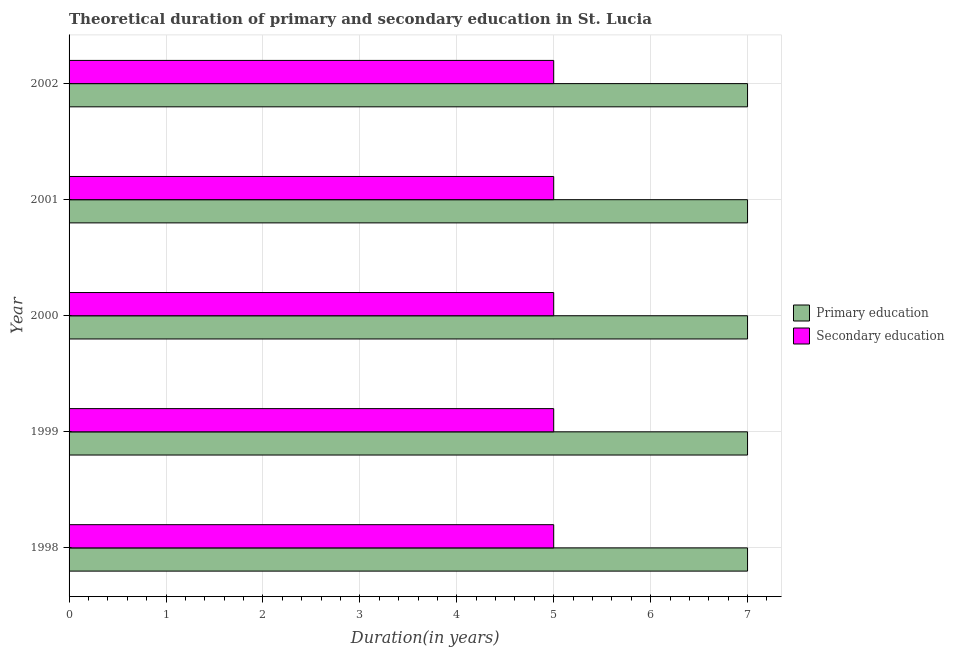Are the number of bars per tick equal to the number of legend labels?
Your answer should be compact. Yes. Are the number of bars on each tick of the Y-axis equal?
Provide a succinct answer. Yes. How many bars are there on the 2nd tick from the bottom?
Your answer should be compact. 2. In how many cases, is the number of bars for a given year not equal to the number of legend labels?
Give a very brief answer. 0. What is the duration of secondary education in 1998?
Give a very brief answer. 5. Across all years, what is the maximum duration of primary education?
Make the answer very short. 7. Across all years, what is the minimum duration of primary education?
Provide a short and direct response. 7. In which year was the duration of secondary education maximum?
Make the answer very short. 1998. What is the total duration of secondary education in the graph?
Give a very brief answer. 25. What is the difference between the duration of secondary education in 2002 and the duration of primary education in 1999?
Give a very brief answer. -2. In the year 1998, what is the difference between the duration of primary education and duration of secondary education?
Offer a terse response. 2. In how many years, is the duration of secondary education greater than 3.4 years?
Your answer should be compact. 5. What is the difference between the highest and the second highest duration of primary education?
Your answer should be compact. 0. What is the difference between the highest and the lowest duration of primary education?
Offer a very short reply. 0. What does the 1st bar from the top in 2002 represents?
Give a very brief answer. Secondary education. What does the 2nd bar from the bottom in 2002 represents?
Give a very brief answer. Secondary education. How many years are there in the graph?
Give a very brief answer. 5. Does the graph contain any zero values?
Your response must be concise. No. How many legend labels are there?
Keep it short and to the point. 2. What is the title of the graph?
Your answer should be compact. Theoretical duration of primary and secondary education in St. Lucia. Does "Chemicals" appear as one of the legend labels in the graph?
Keep it short and to the point. No. What is the label or title of the X-axis?
Ensure brevity in your answer.  Duration(in years). What is the label or title of the Y-axis?
Make the answer very short. Year. What is the Duration(in years) in Primary education in 1999?
Offer a very short reply. 7. What is the Duration(in years) of Primary education in 2000?
Provide a short and direct response. 7. What is the Duration(in years) of Secondary education in 2000?
Give a very brief answer. 5. What is the Duration(in years) in Primary education in 2001?
Offer a terse response. 7. What is the Duration(in years) in Secondary education in 2001?
Offer a terse response. 5. What is the Duration(in years) in Secondary education in 2002?
Make the answer very short. 5. Across all years, what is the maximum Duration(in years) in Primary education?
Give a very brief answer. 7. Across all years, what is the minimum Duration(in years) of Secondary education?
Provide a succinct answer. 5. What is the total Duration(in years) in Primary education in the graph?
Provide a short and direct response. 35. What is the difference between the Duration(in years) of Secondary education in 1998 and that in 1999?
Give a very brief answer. 0. What is the difference between the Duration(in years) of Primary education in 1998 and that in 2000?
Keep it short and to the point. 0. What is the difference between the Duration(in years) in Secondary education in 1998 and that in 2000?
Provide a succinct answer. 0. What is the difference between the Duration(in years) in Primary education in 1998 and that in 2002?
Provide a succinct answer. 0. What is the difference between the Duration(in years) of Secondary education in 1998 and that in 2002?
Your answer should be compact. 0. What is the difference between the Duration(in years) in Secondary education in 1999 and that in 2000?
Ensure brevity in your answer.  0. What is the difference between the Duration(in years) of Primary education in 1999 and that in 2001?
Ensure brevity in your answer.  0. What is the difference between the Duration(in years) of Primary education in 2000 and that in 2001?
Offer a terse response. 0. What is the difference between the Duration(in years) of Primary education in 2000 and that in 2002?
Your response must be concise. 0. What is the difference between the Duration(in years) of Secondary education in 2000 and that in 2002?
Offer a terse response. 0. What is the difference between the Duration(in years) in Primary education in 2001 and that in 2002?
Make the answer very short. 0. What is the difference between the Duration(in years) of Secondary education in 2001 and that in 2002?
Keep it short and to the point. 0. What is the difference between the Duration(in years) of Primary education in 1998 and the Duration(in years) of Secondary education in 2001?
Your response must be concise. 2. What is the difference between the Duration(in years) of Primary education in 1998 and the Duration(in years) of Secondary education in 2002?
Your answer should be very brief. 2. What is the difference between the Duration(in years) of Primary education in 1999 and the Duration(in years) of Secondary education in 2000?
Provide a succinct answer. 2. What is the difference between the Duration(in years) of Primary education in 1999 and the Duration(in years) of Secondary education in 2001?
Provide a succinct answer. 2. What is the difference between the Duration(in years) of Primary education in 2000 and the Duration(in years) of Secondary education in 2001?
Keep it short and to the point. 2. What is the difference between the Duration(in years) of Primary education in 2000 and the Duration(in years) of Secondary education in 2002?
Your response must be concise. 2. What is the difference between the Duration(in years) of Primary education in 2001 and the Duration(in years) of Secondary education in 2002?
Your response must be concise. 2. What is the average Duration(in years) in Primary education per year?
Offer a very short reply. 7. In the year 2000, what is the difference between the Duration(in years) of Primary education and Duration(in years) of Secondary education?
Your answer should be very brief. 2. What is the ratio of the Duration(in years) of Primary education in 1999 to that in 2000?
Give a very brief answer. 1. What is the ratio of the Duration(in years) of Primary education in 1999 to that in 2001?
Ensure brevity in your answer.  1. What is the ratio of the Duration(in years) in Secondary education in 1999 to that in 2001?
Give a very brief answer. 1. What is the ratio of the Duration(in years) of Primary education in 1999 to that in 2002?
Offer a terse response. 1. What is the ratio of the Duration(in years) of Primary education in 2000 to that in 2002?
Your response must be concise. 1. What is the ratio of the Duration(in years) of Primary education in 2001 to that in 2002?
Your answer should be very brief. 1. What is the ratio of the Duration(in years) in Secondary education in 2001 to that in 2002?
Ensure brevity in your answer.  1. What is the difference between the highest and the lowest Duration(in years) of Secondary education?
Offer a terse response. 0. 